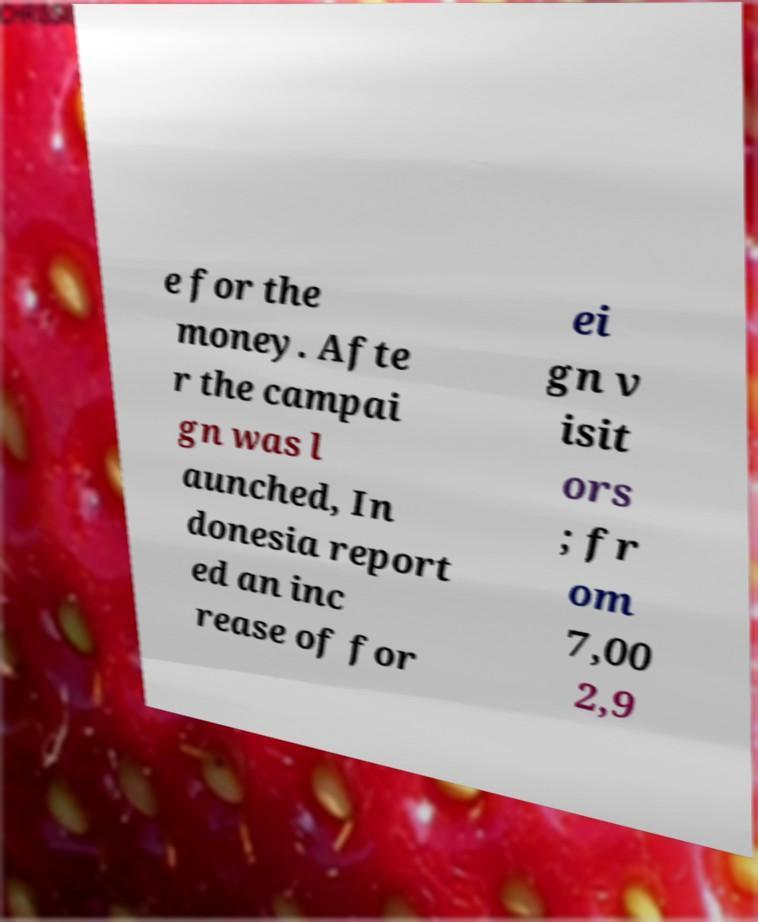Please read and relay the text visible in this image. What does it say? e for the money. Afte r the campai gn was l aunched, In donesia report ed an inc rease of for ei gn v isit ors ; fr om 7,00 2,9 